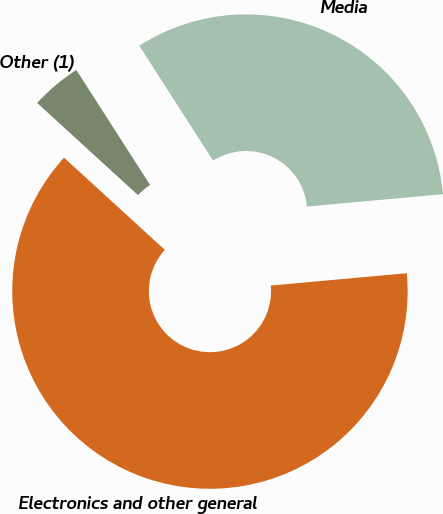Convert chart. <chart><loc_0><loc_0><loc_500><loc_500><pie_chart><fcel>Media<fcel>Electronics and other general<fcel>Other (1)<nl><fcel>32.64%<fcel>63.23%<fcel>4.13%<nl></chart> 